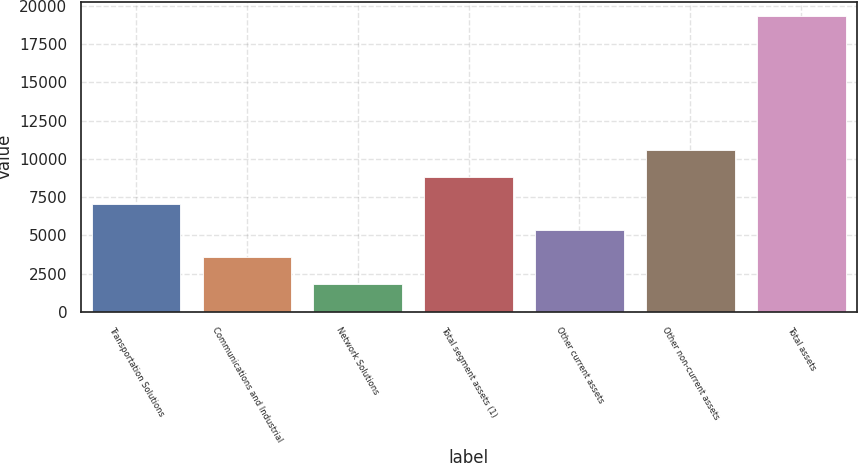Convert chart to OTSL. <chart><loc_0><loc_0><loc_500><loc_500><bar_chart><fcel>Transportation Solutions<fcel>Communications and Industrial<fcel>Network Solutions<fcel>Total segment assets (1)<fcel>Other current assets<fcel>Other non-current assets<fcel>Total assets<nl><fcel>7080.5<fcel>3587.5<fcel>1841<fcel>8827<fcel>5334<fcel>10573.5<fcel>19306<nl></chart> 